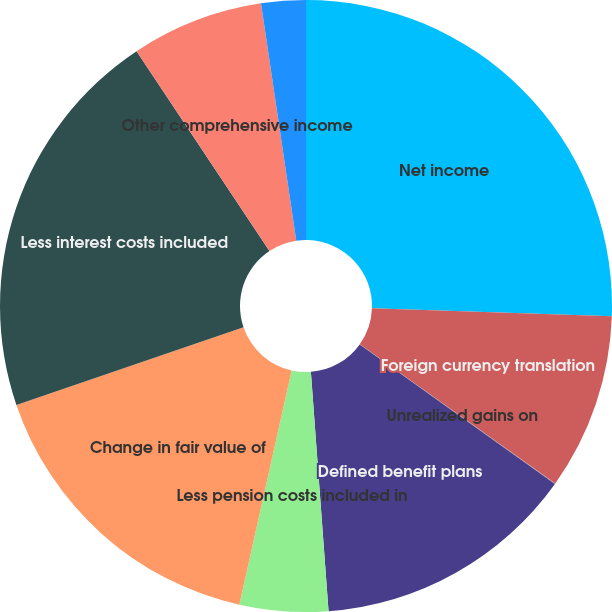Convert chart to OTSL. <chart><loc_0><loc_0><loc_500><loc_500><pie_chart><fcel>Net income<fcel>Foreign currency translation<fcel>Unrealized gains on<fcel>Defined benefit plans<fcel>Less pension costs included in<fcel>Change in fair value of<fcel>Less interest costs included<fcel>Other comprehensive income<fcel>Income taxes (benefits)<nl><fcel>25.54%<fcel>9.31%<fcel>0.03%<fcel>13.95%<fcel>4.67%<fcel>16.27%<fcel>20.9%<fcel>6.99%<fcel>2.35%<nl></chart> 